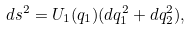<formula> <loc_0><loc_0><loc_500><loc_500>d s ^ { 2 } = U _ { 1 } ( q _ { 1 } ) ( d q _ { 1 } ^ { 2 } + d q _ { 2 } ^ { 2 } ) ,</formula> 